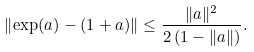Convert formula to latex. <formula><loc_0><loc_0><loc_500><loc_500>\left \| \exp ( a ) - ( 1 + a ) \right \| \leq \frac { \| a \| ^ { 2 } } { 2 \left ( 1 - \| a \| \right ) } .</formula> 